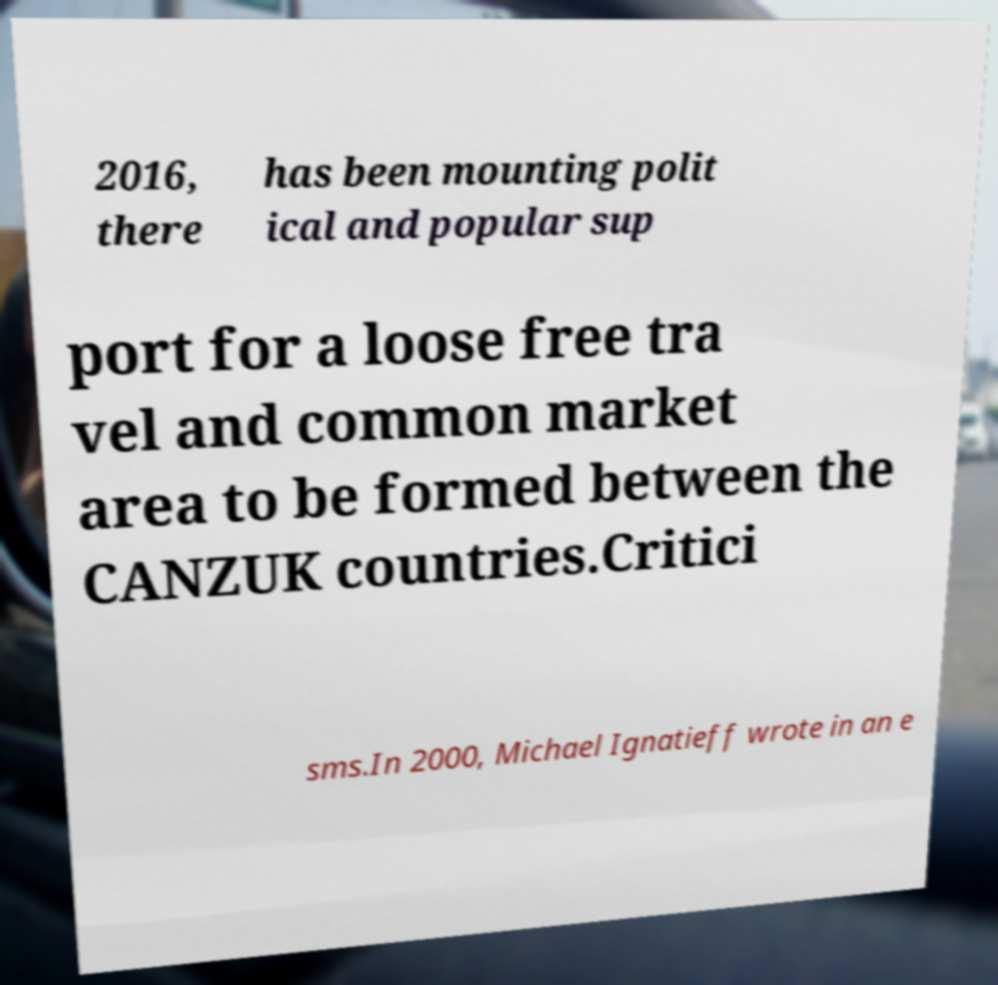Please identify and transcribe the text found in this image. 2016, there has been mounting polit ical and popular sup port for a loose free tra vel and common market area to be formed between the CANZUK countries.Critici sms.In 2000, Michael Ignatieff wrote in an e 